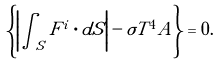<formula> <loc_0><loc_0><loc_500><loc_500>\left \{ \left | \int _ { S } { F } ^ { i } \cdot d { S } \right | - \sigma T ^ { 4 } A \right \} = 0 .</formula> 